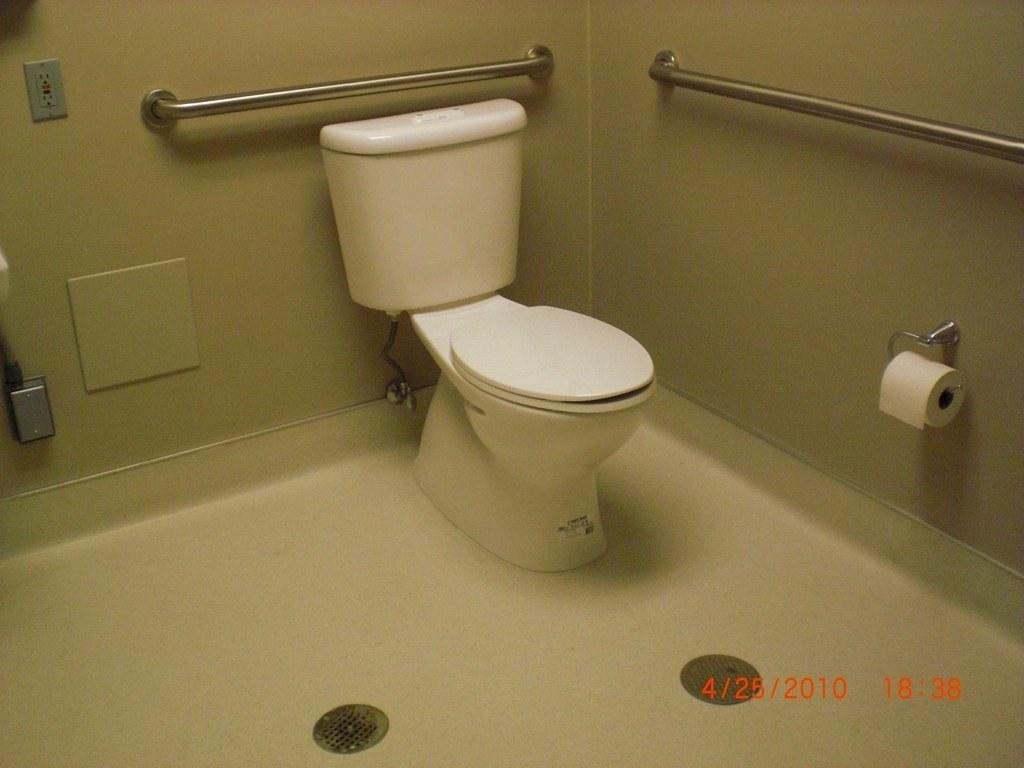Can you describe this image briefly? In this image we can see there is a toilet and two rods are attached to the both sides of the wall, there is a socket and on the left side of the image it's look like a sink and there is an object attached to the wall. On the right side of the image there are toilet papers. At the bottom of the image there are two objects on the floor. 